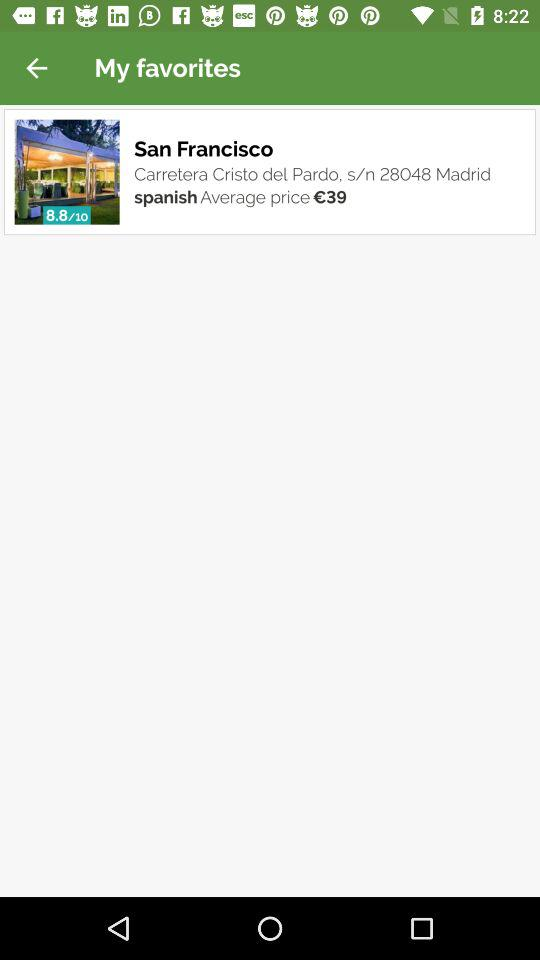What is the average price? The average price is €39. 